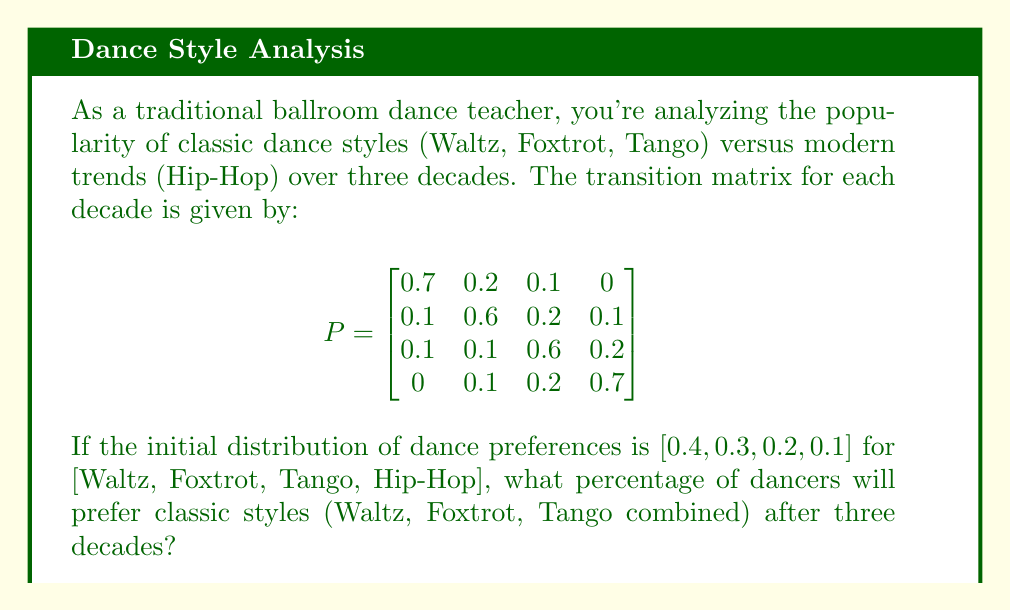Can you solve this math problem? Let's approach this step-by-step:

1) First, we need to calculate the distribution after three decades. This is done by multiplying the initial distribution vector by the transition matrix three times:

   $v_3 = v_0 \cdot P^3$

   Where $v_0 = [0.4, 0.3, 0.2, 0.1]$ and $P$ is the given transition matrix.

2) To calculate $P^3$, we need to multiply $P$ by itself three times. Let's use a computer algebra system for this:

   $$P^3 = \begin{bmatrix}
   0.421 & 0.249 & 0.219 & 0.111 \\
   0.163 & 0.331 & 0.279 & 0.227 \\
   0.163 & 0.249 & 0.309 & 0.279 \\
   0.111 & 0.227 & 0.279 & 0.383
   \end{bmatrix}$$

3) Now, we multiply $v_0$ by $P^3$:

   $v_3 = [0.4, 0.3, 0.2, 0.1] \cdot P^3$

4) Performing this multiplication:

   $v_3 = [0.2852, 0.2847, 0.2571, 0.1730]$

5) To find the percentage of dancers preferring classic styles, we sum the first three elements of $v_3$ (corresponding to Waltz, Foxtrot, and Tango):

   $0.2852 + 0.2847 + 0.2571 = 0.8270$

6) Convert to a percentage:

   $0.8270 \times 100\% = 82.70\%$

Therefore, after three decades, approximately 82.70% of dancers will prefer classic styles.
Answer: 82.70% 